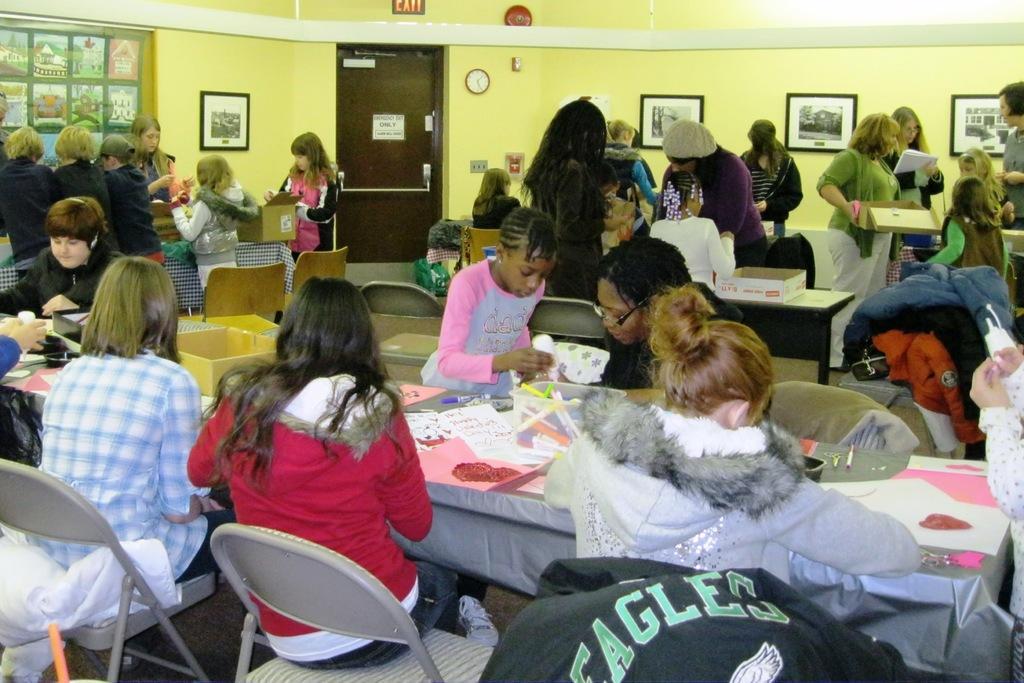Can you describe this image briefly? In the front we can see few persons were sitting on the chair around the table. On table there is a book,papers,pens,box etc. In the background there is a wall,photo frame,door,clock,window and group of persons were standing. 